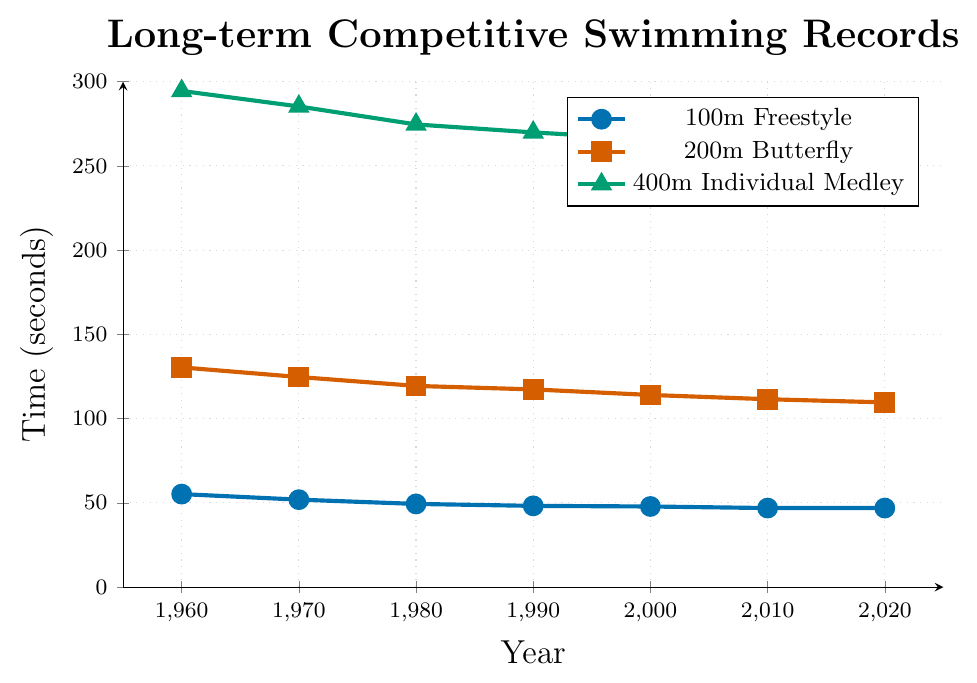What trend can be observed in the 100m Freestyle event from 1960 to 2020? The times for the 100m Freestyle event consistently decrease over the years from 55.2 seconds in 1960 to 46.91 seconds in 2020, indicating improvement in performance.
Answer: Decreasing trend Which swimming event shows the greatest improvement in time from 1960 to 2020? Calculate the difference in times between 1960 and 2020 for each event: 100m Freestyle (55.2 - 46.91 = 8.29 seconds improvement), 200m Butterfly (130.4 - 109.63 = 20.77 seconds improvement), 400m Individual Medley (294.5 - 257.43 = 37.07 seconds improvement). The 400m Individual Medley shows the greatest improvement.
Answer: 400m Individual Medley In what year does the 100m Freestyle event's time become less than 50 seconds? By observing the graph, the 100m Freestyle event's time is below 50 seconds for the first time in 1980 with a time of 49.36 seconds.
Answer: 1980 Compare the times of 200m Butterfly and 400m Individual Medley in the year 2000. Which is faster? In 2000, the 200m Butterfly time is 114.04 seconds and the 400m Individual Medley time is 265.92 seconds. Since smaller times indicate better performance, the 200m Butterfly is faster.
Answer: 200m Butterfly What is the average time improvement per decade for the 400m Individual Medley from 1960 to 2020? First, find the total improvement: 294.5 - 257.43 = 37.07 seconds. The number of decades from 1960 to 2020 is 6. The average improvement per decade is 37.07 / 6 ≈ 6.18 seconds per decade.
Answer: 6.18 seconds Which event has the least change in time from 2010 to 2020? Calculate the change in times for each event between 2010 and 2020: 100m Freestyle (46.91 - 46.91 = 0 seconds), 200m Butterfly (111.51 - 109.63 = 1.88 seconds), 400m Individual Medley (258.10 - 257.43 = 0.67 seconds). The 100m Freestyle has the least change, with no difference over the decade.
Answer: 100m Freestyle What color represents the 200m Butterfly event in the plot? The 200m Butterfly event is represented by the red line with square markers, according to the plot legend.
Answer: Red 